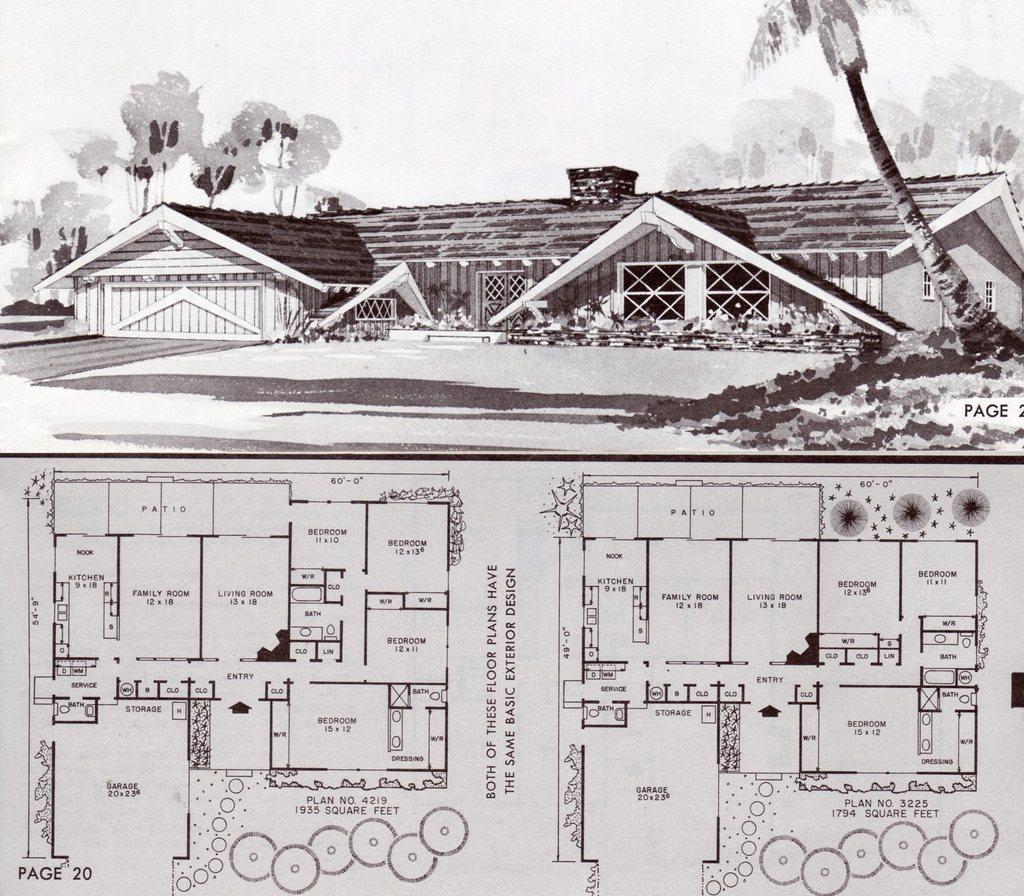Please provide a concise description of this image. At the top of the image it is an edited picture. We can see a house, trees, plants and sky. At the bottom of the image there are planning of houses and something is written on it.   